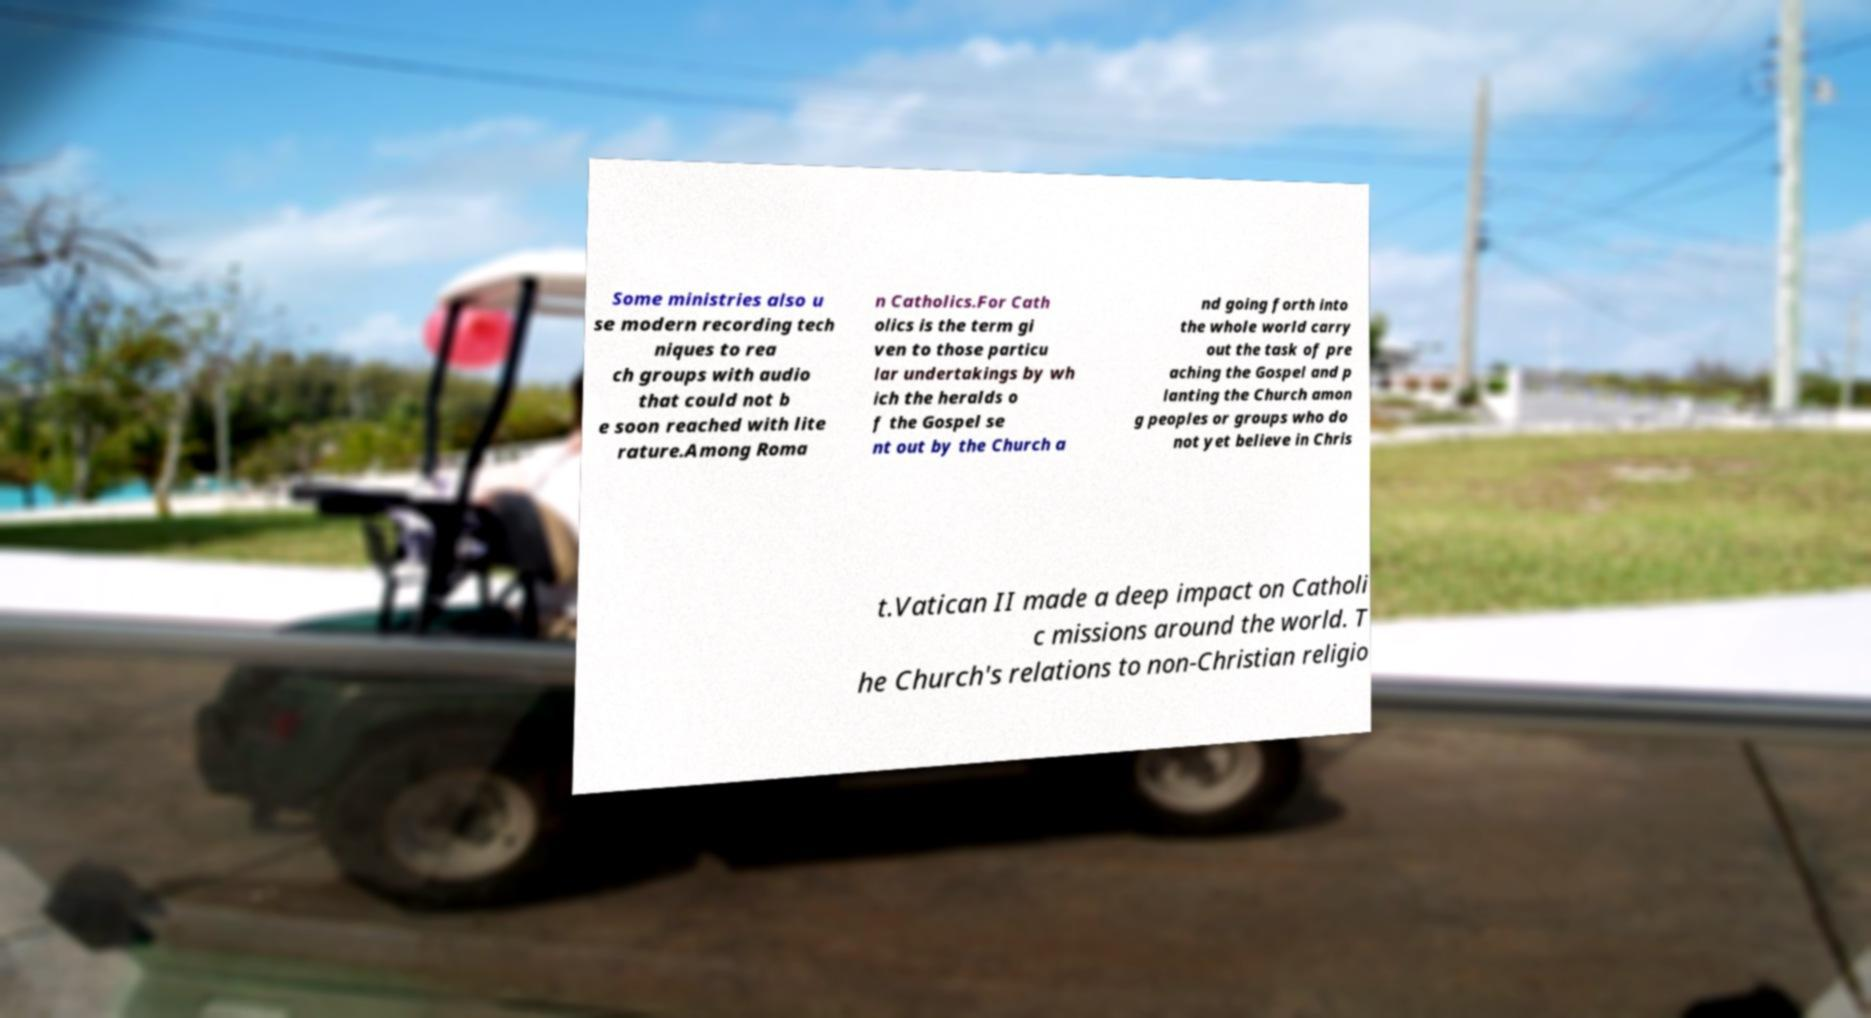I need the written content from this picture converted into text. Can you do that? Some ministries also u se modern recording tech niques to rea ch groups with audio that could not b e soon reached with lite rature.Among Roma n Catholics.For Cath olics is the term gi ven to those particu lar undertakings by wh ich the heralds o f the Gospel se nt out by the Church a nd going forth into the whole world carry out the task of pre aching the Gospel and p lanting the Church amon g peoples or groups who do not yet believe in Chris t.Vatican II made a deep impact on Catholi c missions around the world. T he Church's relations to non-Christian religio 